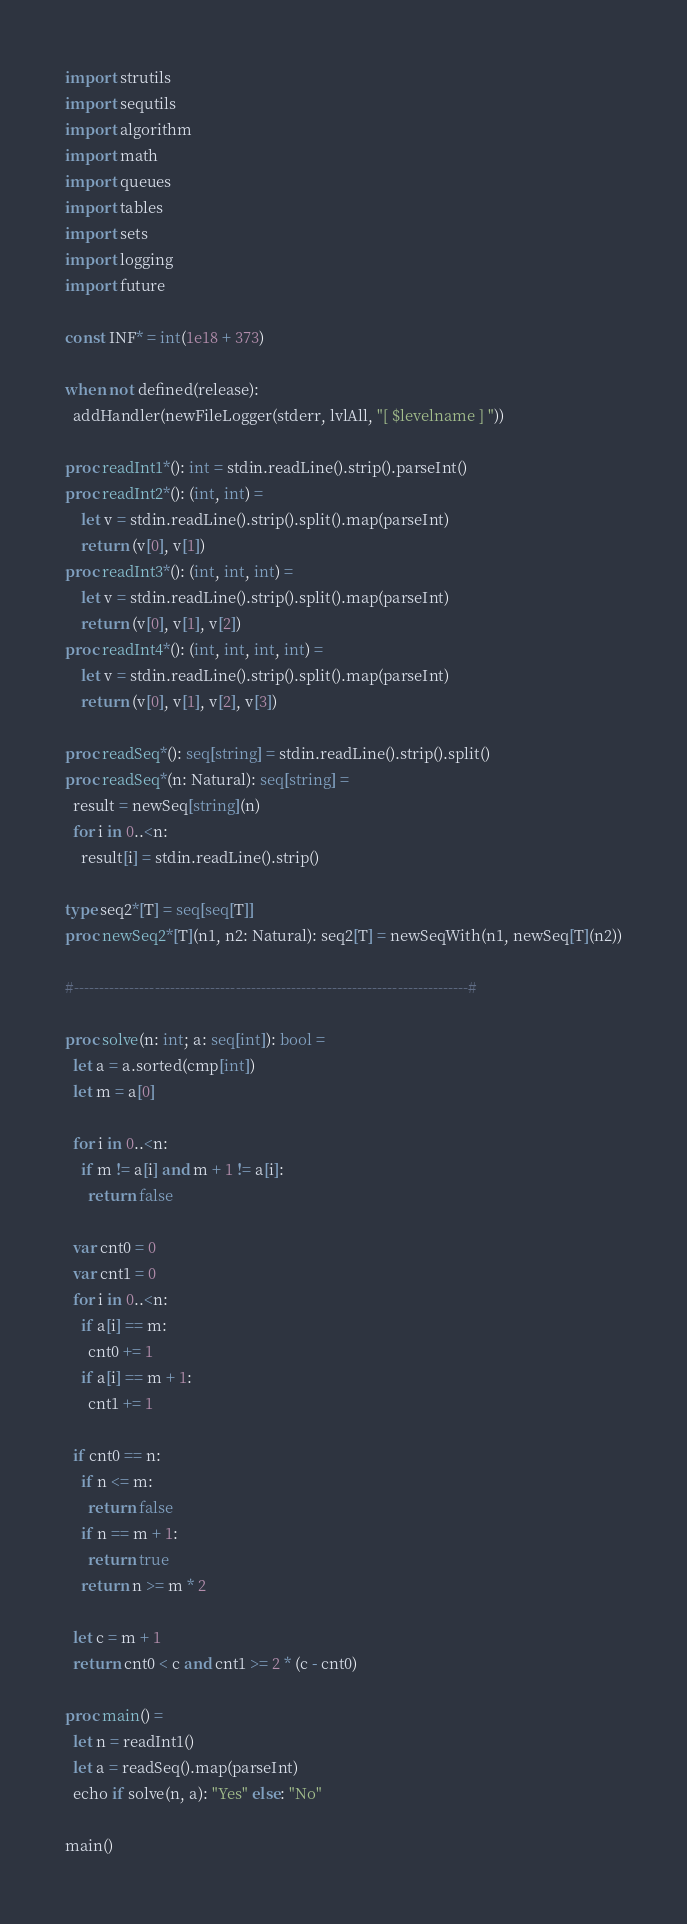Convert code to text. <code><loc_0><loc_0><loc_500><loc_500><_Nim_>import strutils
import sequtils
import algorithm
import math
import queues
import tables
import sets
import logging
import future

const INF* = int(1e18 + 373)

when not defined(release):
  addHandler(newFileLogger(stderr, lvlAll, "[ $levelname ] "))

proc readInt1*(): int = stdin.readLine().strip().parseInt()
proc readInt2*(): (int, int) =
    let v = stdin.readLine().strip().split().map(parseInt)
    return (v[0], v[1])
proc readInt3*(): (int, int, int) =
    let v = stdin.readLine().strip().split().map(parseInt)
    return (v[0], v[1], v[2])
proc readInt4*(): (int, int, int, int) =
    let v = stdin.readLine().strip().split().map(parseInt)
    return (v[0], v[1], v[2], v[3])

proc readSeq*(): seq[string] = stdin.readLine().strip().split()
proc readSeq*(n: Natural): seq[string] =
  result = newSeq[string](n)
  for i in 0..<n:
    result[i] = stdin.readLine().strip()

type seq2*[T] = seq[seq[T]]
proc newSeq2*[T](n1, n2: Natural): seq2[T] = newSeqWith(n1, newSeq[T](n2))

#------------------------------------------------------------------------------#

proc solve(n: int; a: seq[int]): bool =
  let a = a.sorted(cmp[int])
  let m = a[0]

  for i in 0..<n:
    if m != a[i] and m + 1 != a[i]:
      return false

  var cnt0 = 0
  var cnt1 = 0
  for i in 0..<n:
    if a[i] == m:
      cnt0 += 1
    if a[i] == m + 1:
      cnt1 += 1

  if cnt0 == n:
    if n <= m:
      return false
    if n == m + 1:
      return true
    return n >= m * 2

  let c = m + 1
  return cnt0 < c and cnt1 >= 2 * (c - cnt0)

proc main() =
  let n = readInt1()
  let a = readSeq().map(parseInt)
  echo if solve(n, a): "Yes" else: "No"

main()

</code> 